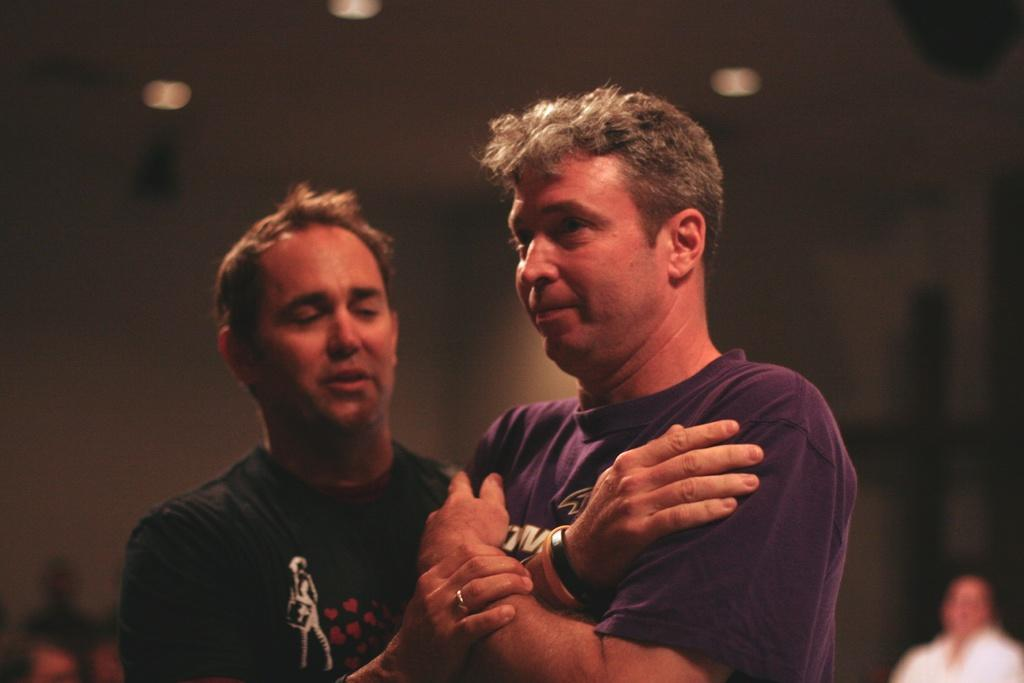How many people are in the image? There are two persons standing in the image. What are the two persons doing in the image? One person is holding the hand of the other person. Can you describe the background of the image? The background of the image is blurred. Where is the throne located in the image? There is no throne present in the image. What type of organization is depicted in the image? There is no organization depicted in the image; it features two persons standing together. 